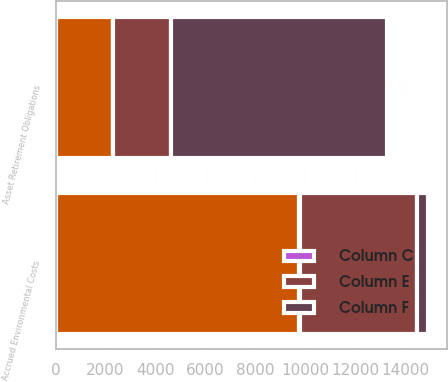Convert chart. <chart><loc_0><loc_0><loc_500><loc_500><stacked_bar_chart><ecel><fcel>Asset Retirement Obligations<fcel>Accrued Environmental Costs<nl><fcel>nan<fcel>2314<fcel>9756<nl><fcel>Column F<fcel>8641<fcel>451<nl><fcel>Column E<fcel>2314<fcel>4698<nl><fcel>Column C<fcel>2<fcel>7<nl></chart> 